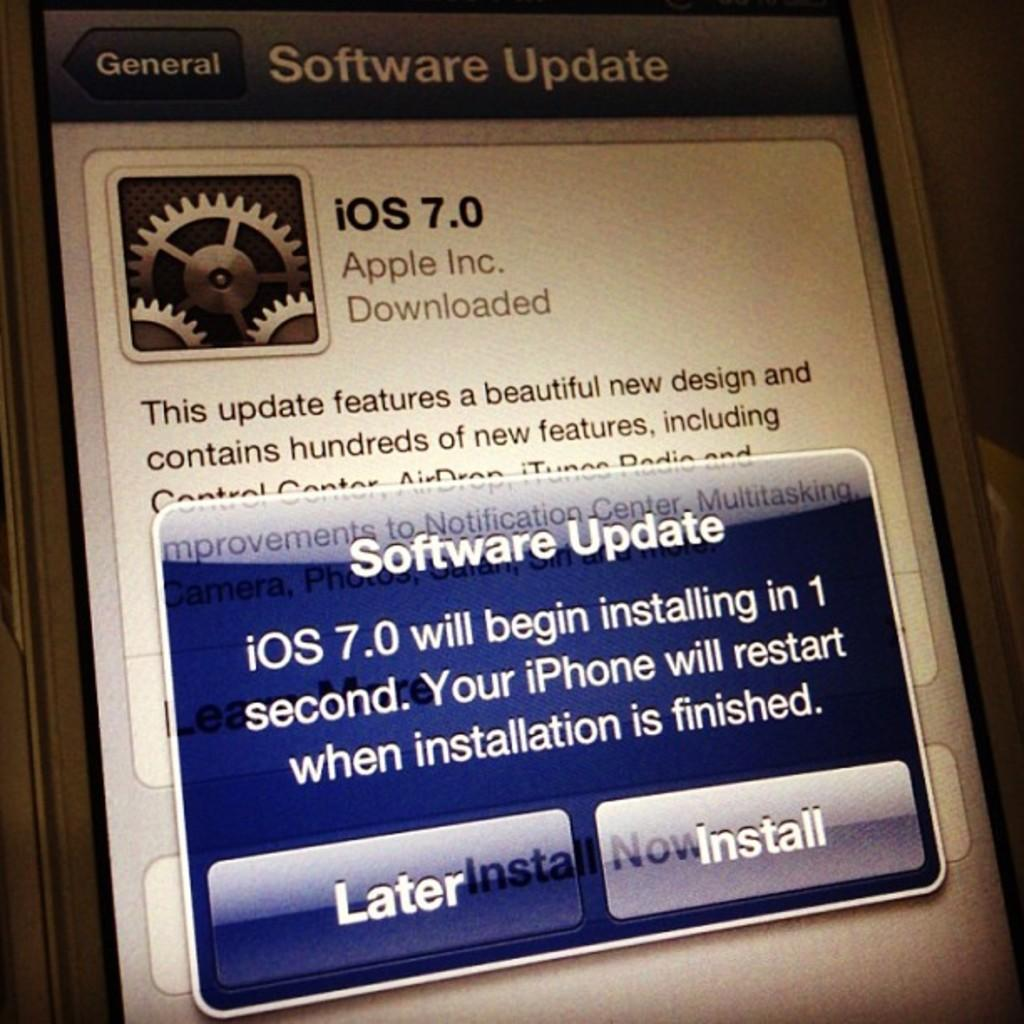<image>
Create a compact narrative representing the image presented. Phone screen that has a popup saying it needs a software update. 